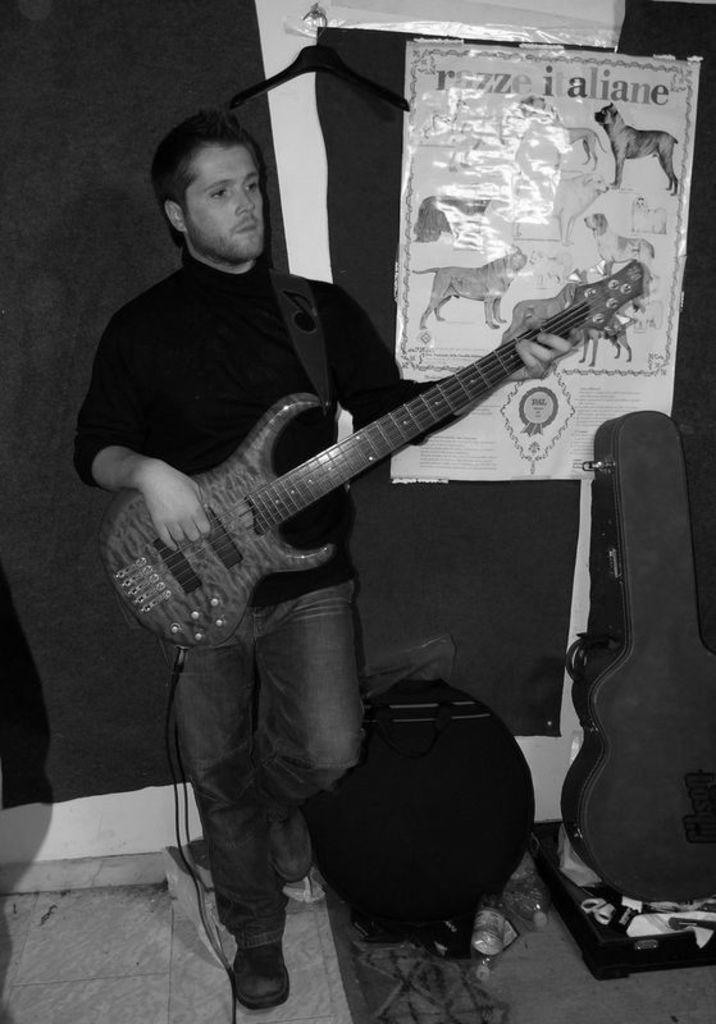Please provide a concise description of this image. The photo is taken inside a room. A man is playing guitar. He is wearing a black t-shirt. Behind him there is a hanger , there is curtain on it there is a poster. Beside the man there is bag and few other things. 